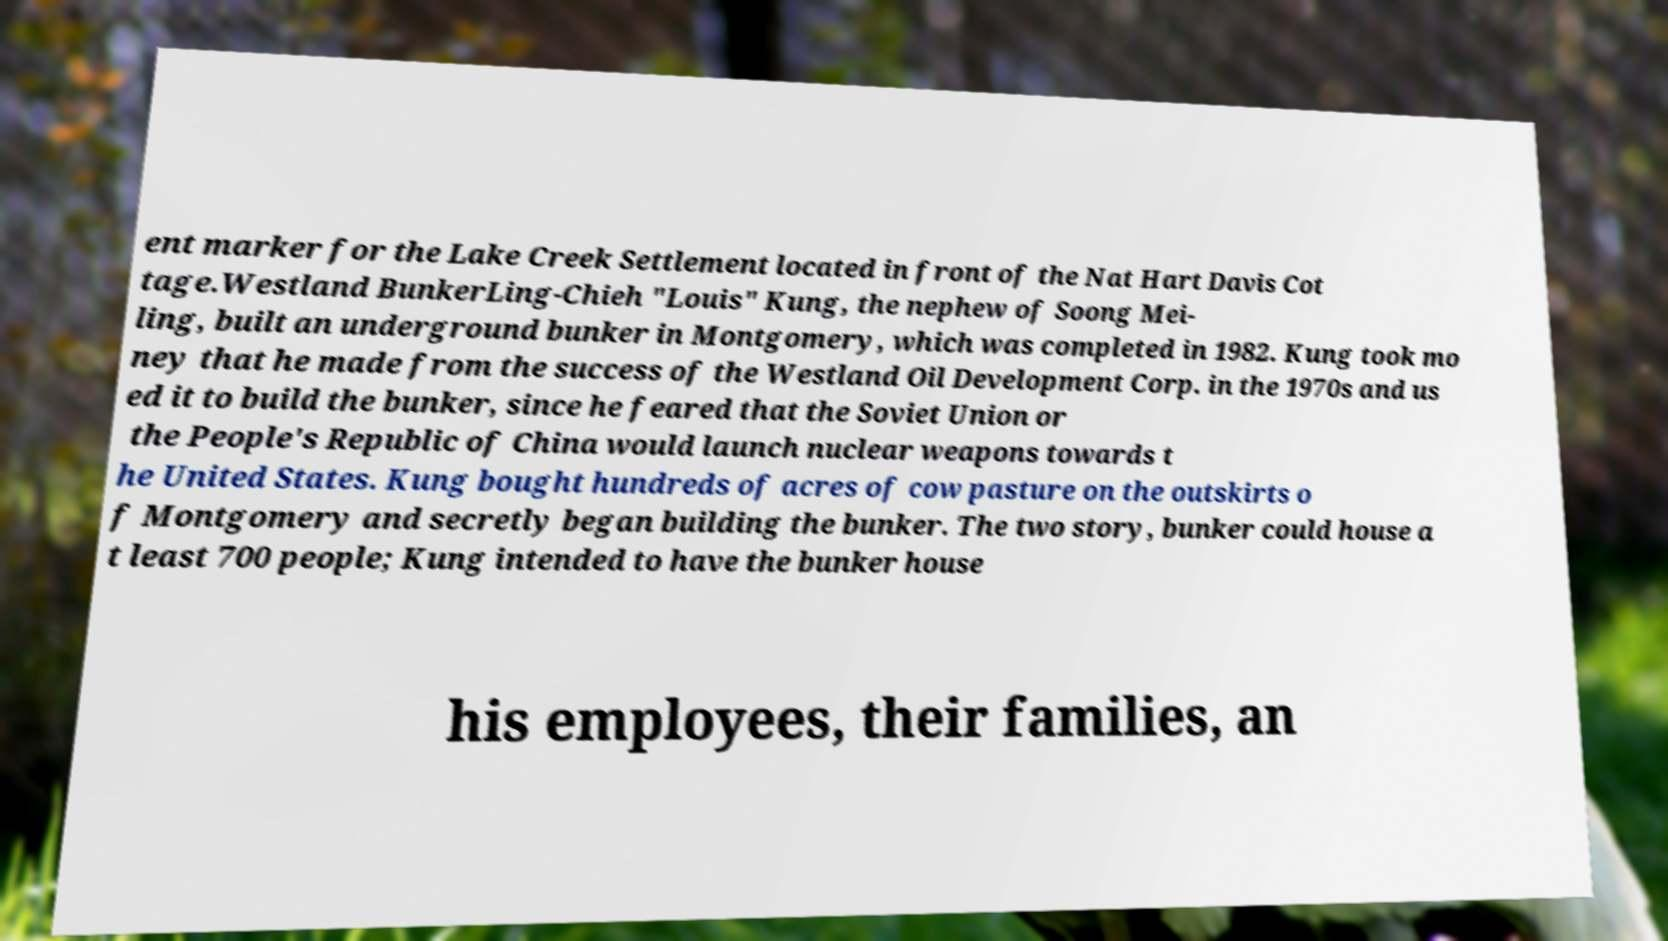Please identify and transcribe the text found in this image. ent marker for the Lake Creek Settlement located in front of the Nat Hart Davis Cot tage.Westland BunkerLing-Chieh "Louis" Kung, the nephew of Soong Mei- ling, built an underground bunker in Montgomery, which was completed in 1982. Kung took mo ney that he made from the success of the Westland Oil Development Corp. in the 1970s and us ed it to build the bunker, since he feared that the Soviet Union or the People's Republic of China would launch nuclear weapons towards t he United States. Kung bought hundreds of acres of cow pasture on the outskirts o f Montgomery and secretly began building the bunker. The two story, bunker could house a t least 700 people; Kung intended to have the bunker house his employees, their families, an 